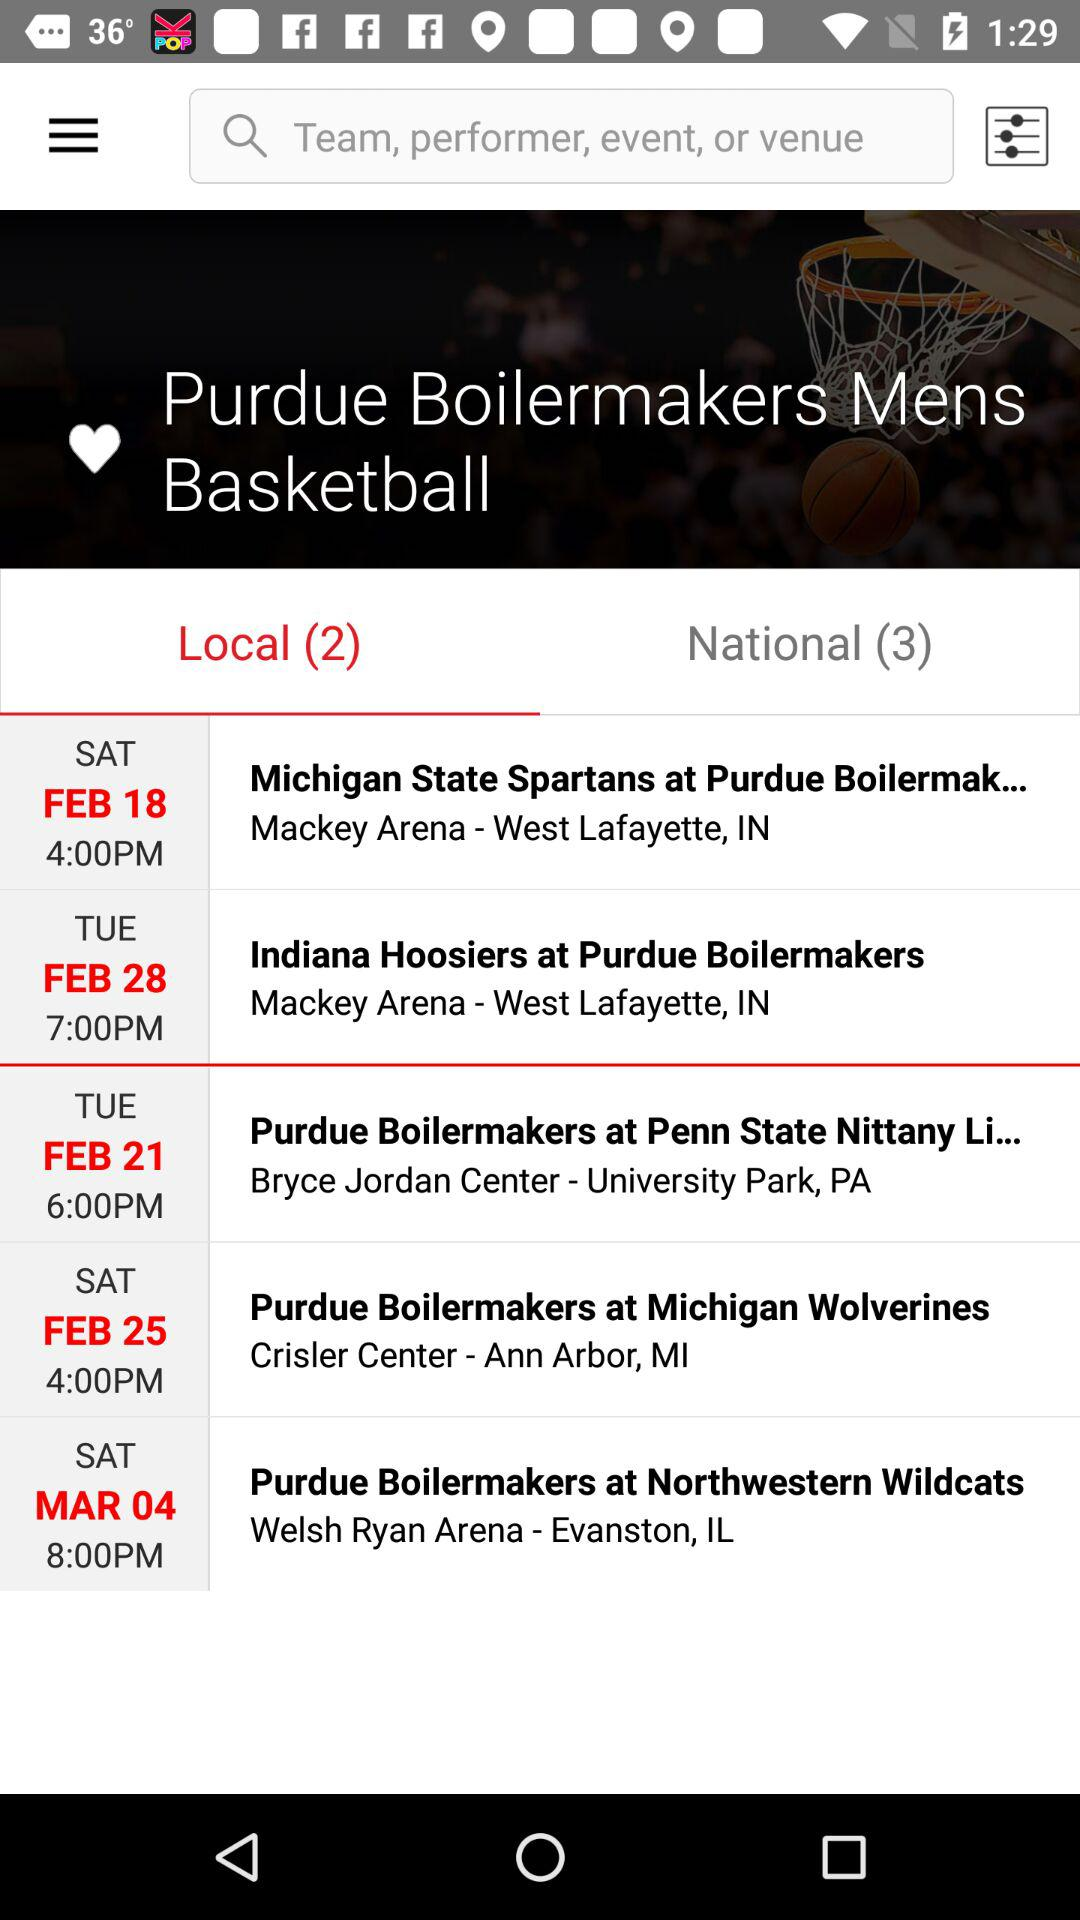What is the date of "Michigan State Spartans at Purdue Boilermak..."? The date of "Michigan State Spartans at Purdue Boilermak..." is February 18. 